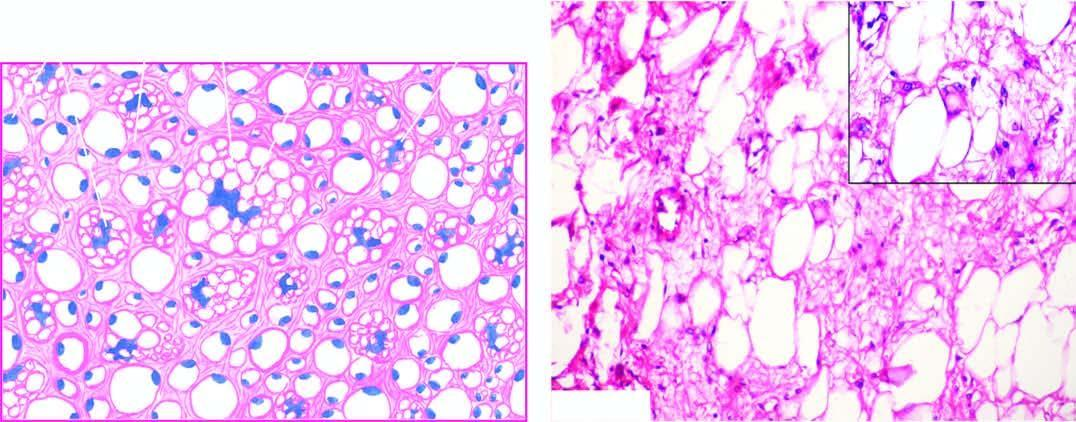does the tuft show close-up view of a typical lipoblast having multivacuolated cytoplasm indenting the atypical nucleus?
Answer the question using a single word or phrase. No 